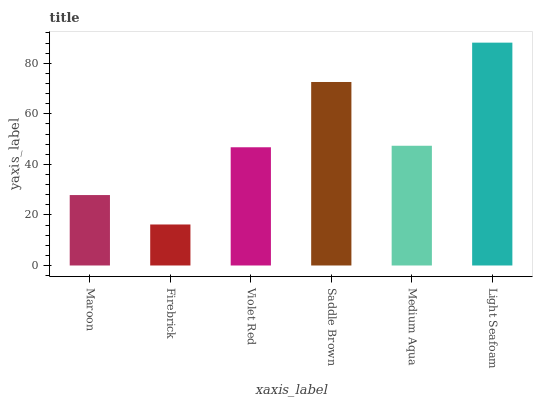Is Firebrick the minimum?
Answer yes or no. Yes. Is Light Seafoam the maximum?
Answer yes or no. Yes. Is Violet Red the minimum?
Answer yes or no. No. Is Violet Red the maximum?
Answer yes or no. No. Is Violet Red greater than Firebrick?
Answer yes or no. Yes. Is Firebrick less than Violet Red?
Answer yes or no. Yes. Is Firebrick greater than Violet Red?
Answer yes or no. No. Is Violet Red less than Firebrick?
Answer yes or no. No. Is Medium Aqua the high median?
Answer yes or no. Yes. Is Violet Red the low median?
Answer yes or no. Yes. Is Light Seafoam the high median?
Answer yes or no. No. Is Maroon the low median?
Answer yes or no. No. 